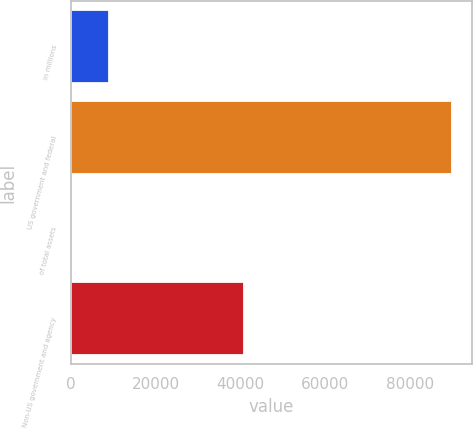Convert chart. <chart><loc_0><loc_0><loc_500><loc_500><bar_chart><fcel>in millions<fcel>US government and federal<fcel>of total assets<fcel>Non-US government and agency<nl><fcel>9020.71<fcel>90118<fcel>9.9<fcel>40944<nl></chart> 